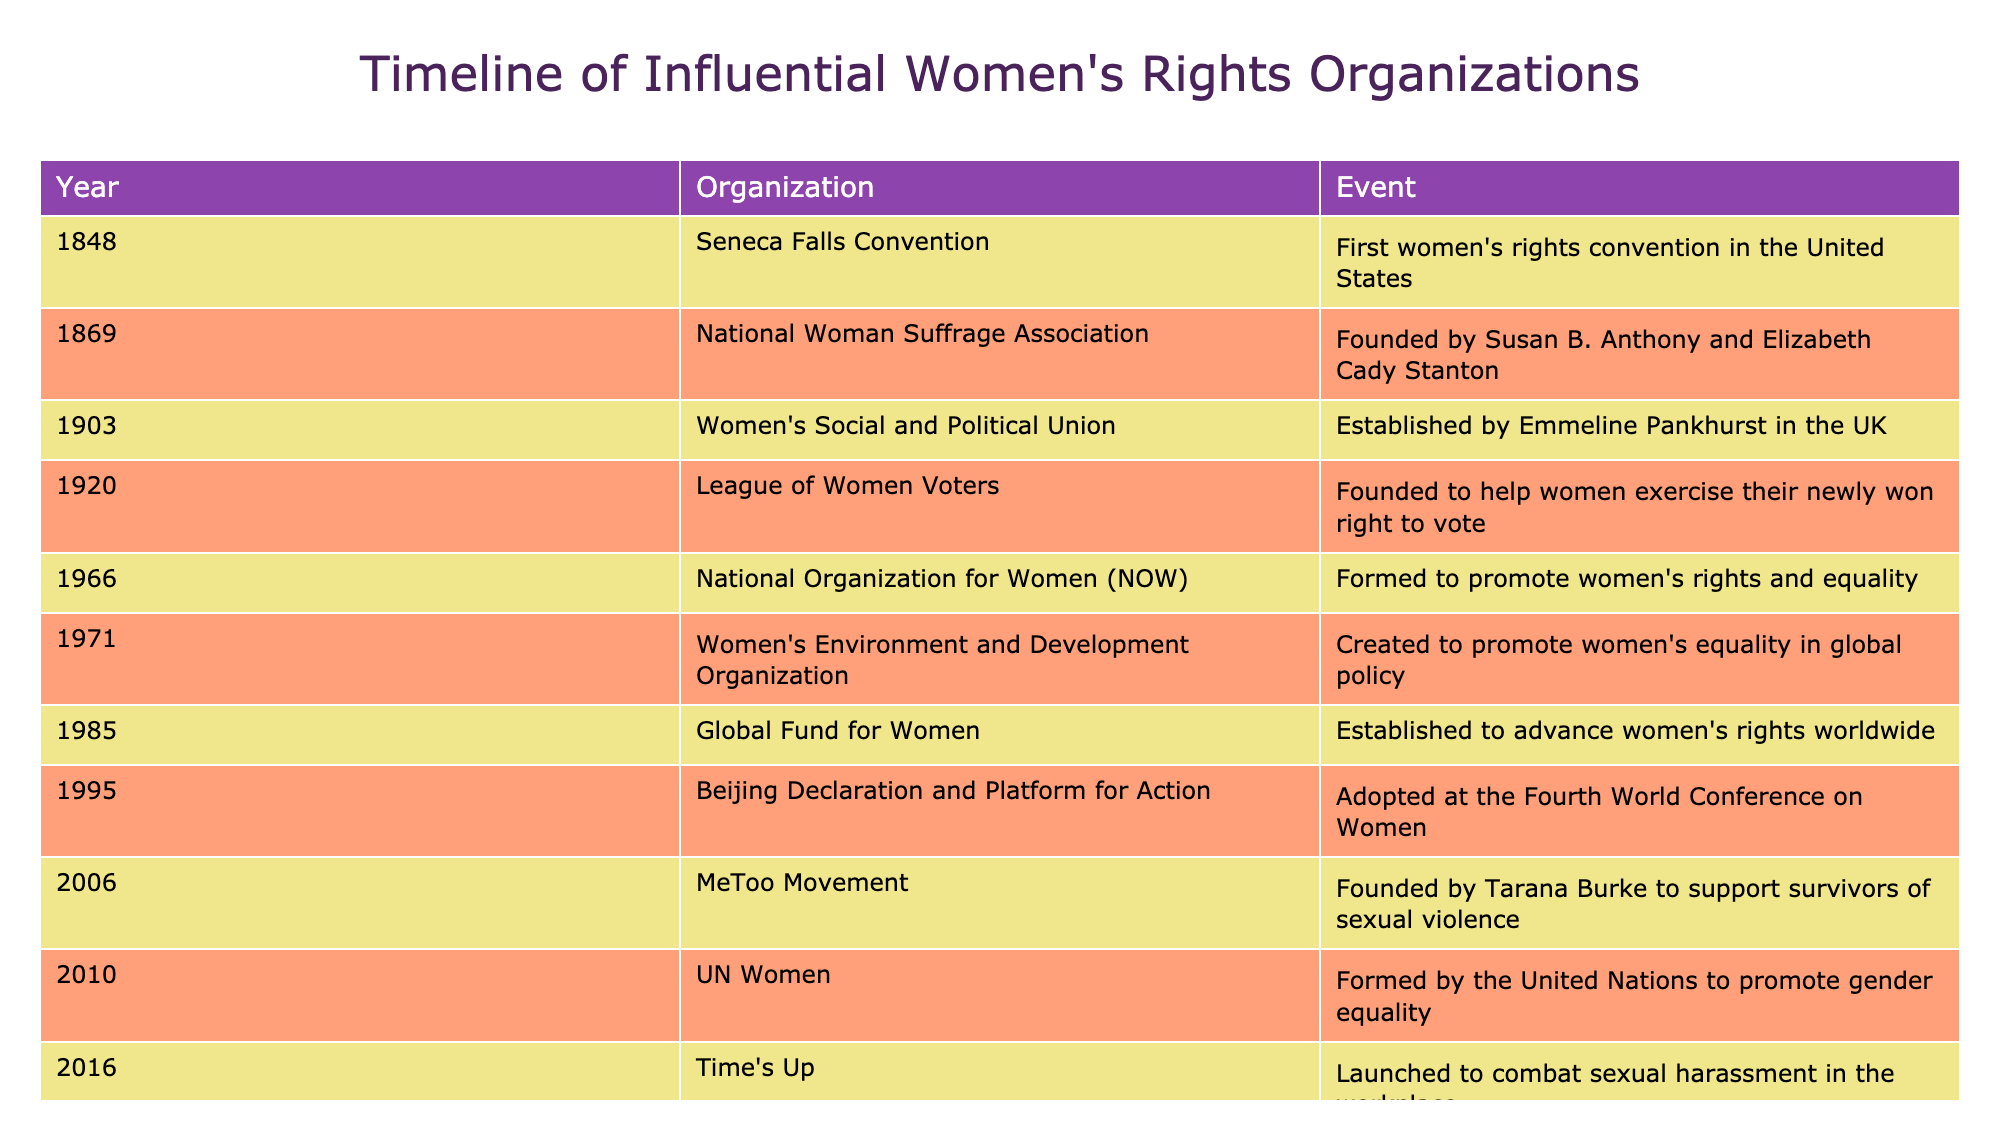What year was the Seneca Falls Convention held? The table lists the events and their corresponding years. The Seneca Falls Convention is recorded under the year 1848.
Answer: 1848 Which organization was founded first? By examining the list from top to bottom, the first organization mentioned is the Seneca Falls Convention in 1848.
Answer: Seneca Falls Convention How many organizations were founded in the 20th century? The organizations founded in the 20th century are: Women's Social and Political Union (1903), League of Women Voters (1920), National Organization for Women (1966), Women's Environment and Development Organization (1971), Global Fund for Women (1985), and Beijing Declaration and Platform for Action (1995). That makes a total of 6 organizations.
Answer: 6 Did the MeToo Movement come before UN Women? The MeToo Movement was founded in 2006, while UN Women was formed in 2010. Therefore, the answer to the question is no.
Answer: No What is the difference in years between the founding of the National Woman Suffrage Association and the Women's Social and Political Union? The National Woman Suffrage Association was founded in 1869, and the Women's Social and Political Union was established in 1903. To find the difference, we subtract the earlier year from the later one: 1903 - 1869 = 34 years.
Answer: 34 years Which organization has a founding date closest to 2017? The Women's March is recorded in 2017, and the organization above it, Time's Up, was launched in 2016. Hence, Time's Up is closest to 2017 as it was founded just a year prior.
Answer: Time's Up Are there any organizations founded after 2000 focused specifically on combating sexual violence? The table shows the MeToo Movement founded in 2006, which directly aligns with combatting sexual violence and is indeed post-2000. Thus, the answer is yes.
Answer: Yes How many events listed occurred in the 1960s and beyond? The events in the 1960s and beyond include: National Organization for Women (1966), Women's Environment and Development Organization (1971), Global Fund for Women (1985), Beijing Declaration and Platform for Action (1995), MeToo Movement (2006), Time's Up (2016), and Women's March (2017). Counting these gives a total of 7 events.
Answer: 7 What organization was formed to specifically promote global policy concerning women's equality? The Women's Environment and Development Organization, founded in 1971, was created specifically to promote women's equality in global policy.
Answer: Women's Environment and Development Organization 